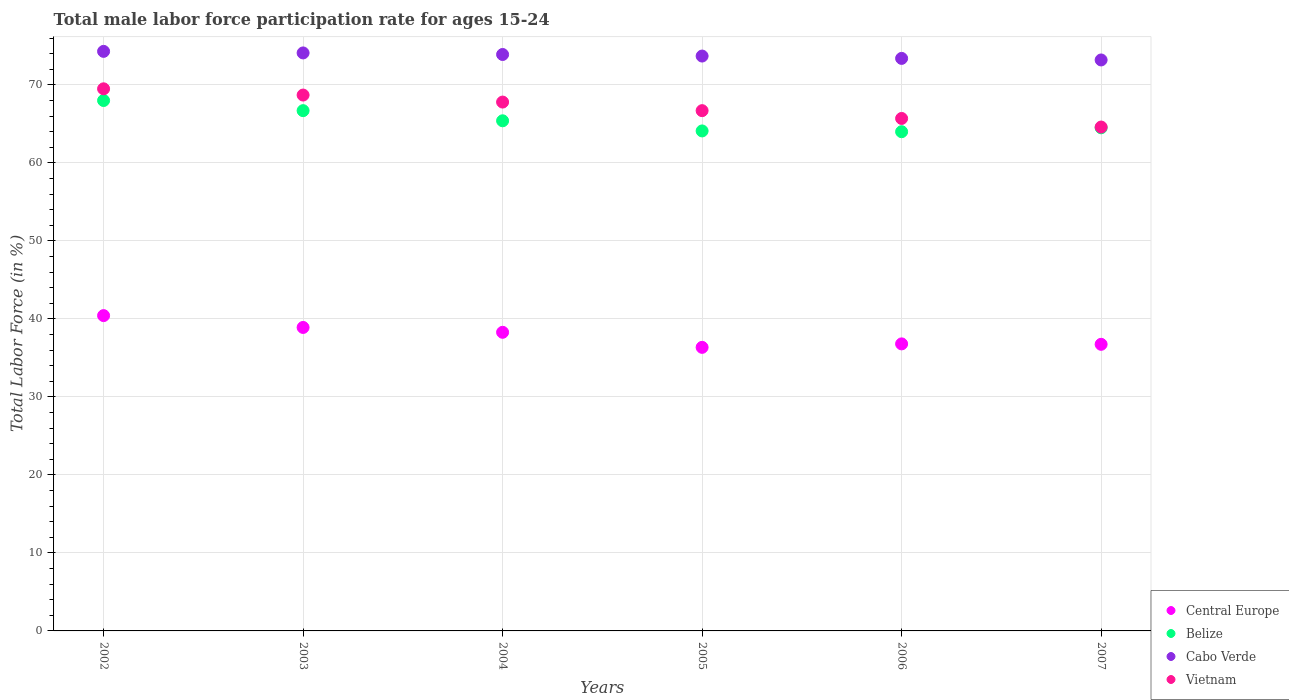How many different coloured dotlines are there?
Offer a terse response. 4. Is the number of dotlines equal to the number of legend labels?
Keep it short and to the point. Yes. What is the male labor force participation rate in Vietnam in 2005?
Provide a succinct answer. 66.7. Across all years, what is the maximum male labor force participation rate in Cabo Verde?
Your answer should be compact. 74.3. Across all years, what is the minimum male labor force participation rate in Cabo Verde?
Provide a short and direct response. 73.2. In which year was the male labor force participation rate in Central Europe minimum?
Your answer should be very brief. 2005. What is the total male labor force participation rate in Belize in the graph?
Keep it short and to the point. 392.7. What is the difference between the male labor force participation rate in Central Europe in 2002 and that in 2004?
Your response must be concise. 2.14. What is the difference between the male labor force participation rate in Belize in 2006 and the male labor force participation rate in Cabo Verde in 2003?
Your answer should be compact. -10.1. What is the average male labor force participation rate in Belize per year?
Provide a succinct answer. 65.45. In the year 2004, what is the difference between the male labor force participation rate in Vietnam and male labor force participation rate in Cabo Verde?
Keep it short and to the point. -6.1. In how many years, is the male labor force participation rate in Vietnam greater than 30 %?
Offer a terse response. 6. What is the ratio of the male labor force participation rate in Cabo Verde in 2002 to that in 2005?
Make the answer very short. 1.01. What is the difference between the highest and the second highest male labor force participation rate in Central Europe?
Your answer should be very brief. 1.52. What is the difference between the highest and the lowest male labor force participation rate in Cabo Verde?
Provide a short and direct response. 1.1. Is it the case that in every year, the sum of the male labor force participation rate in Vietnam and male labor force participation rate in Belize  is greater than the sum of male labor force participation rate in Central Europe and male labor force participation rate in Cabo Verde?
Offer a very short reply. No. Is it the case that in every year, the sum of the male labor force participation rate in Cabo Verde and male labor force participation rate in Central Europe  is greater than the male labor force participation rate in Belize?
Your answer should be compact. Yes. Does the male labor force participation rate in Belize monotonically increase over the years?
Your answer should be very brief. No. Are the values on the major ticks of Y-axis written in scientific E-notation?
Your answer should be very brief. No. Does the graph contain grids?
Your answer should be very brief. Yes. Where does the legend appear in the graph?
Ensure brevity in your answer.  Bottom right. How many legend labels are there?
Ensure brevity in your answer.  4. How are the legend labels stacked?
Your response must be concise. Vertical. What is the title of the graph?
Offer a terse response. Total male labor force participation rate for ages 15-24. Does "Bulgaria" appear as one of the legend labels in the graph?
Give a very brief answer. No. What is the label or title of the X-axis?
Make the answer very short. Years. What is the label or title of the Y-axis?
Your response must be concise. Total Labor Force (in %). What is the Total Labor Force (in %) of Central Europe in 2002?
Your answer should be compact. 40.42. What is the Total Labor Force (in %) in Belize in 2002?
Make the answer very short. 68. What is the Total Labor Force (in %) in Cabo Verde in 2002?
Provide a succinct answer. 74.3. What is the Total Labor Force (in %) in Vietnam in 2002?
Keep it short and to the point. 69.5. What is the Total Labor Force (in %) of Central Europe in 2003?
Your answer should be very brief. 38.91. What is the Total Labor Force (in %) in Belize in 2003?
Ensure brevity in your answer.  66.7. What is the Total Labor Force (in %) of Cabo Verde in 2003?
Give a very brief answer. 74.1. What is the Total Labor Force (in %) of Vietnam in 2003?
Provide a short and direct response. 68.7. What is the Total Labor Force (in %) of Central Europe in 2004?
Your answer should be compact. 38.28. What is the Total Labor Force (in %) in Belize in 2004?
Your answer should be very brief. 65.4. What is the Total Labor Force (in %) of Cabo Verde in 2004?
Your response must be concise. 73.9. What is the Total Labor Force (in %) in Vietnam in 2004?
Your answer should be very brief. 67.8. What is the Total Labor Force (in %) in Central Europe in 2005?
Offer a very short reply. 36.35. What is the Total Labor Force (in %) in Belize in 2005?
Keep it short and to the point. 64.1. What is the Total Labor Force (in %) of Cabo Verde in 2005?
Your answer should be compact. 73.7. What is the Total Labor Force (in %) in Vietnam in 2005?
Give a very brief answer. 66.7. What is the Total Labor Force (in %) in Central Europe in 2006?
Make the answer very short. 36.8. What is the Total Labor Force (in %) of Cabo Verde in 2006?
Your response must be concise. 73.4. What is the Total Labor Force (in %) of Vietnam in 2006?
Your answer should be very brief. 65.7. What is the Total Labor Force (in %) of Central Europe in 2007?
Provide a succinct answer. 36.74. What is the Total Labor Force (in %) in Belize in 2007?
Ensure brevity in your answer.  64.5. What is the Total Labor Force (in %) in Cabo Verde in 2007?
Keep it short and to the point. 73.2. What is the Total Labor Force (in %) in Vietnam in 2007?
Your answer should be very brief. 64.6. Across all years, what is the maximum Total Labor Force (in %) of Central Europe?
Your answer should be very brief. 40.42. Across all years, what is the maximum Total Labor Force (in %) of Belize?
Your answer should be very brief. 68. Across all years, what is the maximum Total Labor Force (in %) in Cabo Verde?
Provide a short and direct response. 74.3. Across all years, what is the maximum Total Labor Force (in %) of Vietnam?
Ensure brevity in your answer.  69.5. Across all years, what is the minimum Total Labor Force (in %) in Central Europe?
Give a very brief answer. 36.35. Across all years, what is the minimum Total Labor Force (in %) in Belize?
Offer a terse response. 64. Across all years, what is the minimum Total Labor Force (in %) in Cabo Verde?
Your answer should be compact. 73.2. Across all years, what is the minimum Total Labor Force (in %) in Vietnam?
Make the answer very short. 64.6. What is the total Total Labor Force (in %) of Central Europe in the graph?
Your answer should be very brief. 227.51. What is the total Total Labor Force (in %) of Belize in the graph?
Keep it short and to the point. 392.7. What is the total Total Labor Force (in %) of Cabo Verde in the graph?
Give a very brief answer. 442.6. What is the total Total Labor Force (in %) of Vietnam in the graph?
Keep it short and to the point. 403. What is the difference between the Total Labor Force (in %) in Central Europe in 2002 and that in 2003?
Give a very brief answer. 1.52. What is the difference between the Total Labor Force (in %) of Belize in 2002 and that in 2003?
Provide a succinct answer. 1.3. What is the difference between the Total Labor Force (in %) of Cabo Verde in 2002 and that in 2003?
Offer a very short reply. 0.2. What is the difference between the Total Labor Force (in %) of Vietnam in 2002 and that in 2003?
Make the answer very short. 0.8. What is the difference between the Total Labor Force (in %) in Central Europe in 2002 and that in 2004?
Your response must be concise. 2.14. What is the difference between the Total Labor Force (in %) in Cabo Verde in 2002 and that in 2004?
Your answer should be very brief. 0.4. What is the difference between the Total Labor Force (in %) in Central Europe in 2002 and that in 2005?
Provide a short and direct response. 4.07. What is the difference between the Total Labor Force (in %) of Belize in 2002 and that in 2005?
Your response must be concise. 3.9. What is the difference between the Total Labor Force (in %) in Cabo Verde in 2002 and that in 2005?
Provide a succinct answer. 0.6. What is the difference between the Total Labor Force (in %) of Vietnam in 2002 and that in 2005?
Your answer should be very brief. 2.8. What is the difference between the Total Labor Force (in %) of Central Europe in 2002 and that in 2006?
Your response must be concise. 3.62. What is the difference between the Total Labor Force (in %) in Belize in 2002 and that in 2006?
Make the answer very short. 4. What is the difference between the Total Labor Force (in %) in Central Europe in 2002 and that in 2007?
Your response must be concise. 3.68. What is the difference between the Total Labor Force (in %) in Central Europe in 2003 and that in 2004?
Provide a short and direct response. 0.62. What is the difference between the Total Labor Force (in %) in Belize in 2003 and that in 2004?
Your response must be concise. 1.3. What is the difference between the Total Labor Force (in %) of Cabo Verde in 2003 and that in 2004?
Provide a succinct answer. 0.2. What is the difference between the Total Labor Force (in %) in Central Europe in 2003 and that in 2005?
Offer a very short reply. 2.55. What is the difference between the Total Labor Force (in %) of Central Europe in 2003 and that in 2006?
Your answer should be very brief. 2.11. What is the difference between the Total Labor Force (in %) of Belize in 2003 and that in 2006?
Provide a succinct answer. 2.7. What is the difference between the Total Labor Force (in %) of Central Europe in 2003 and that in 2007?
Offer a terse response. 2.16. What is the difference between the Total Labor Force (in %) in Belize in 2003 and that in 2007?
Offer a terse response. 2.2. What is the difference between the Total Labor Force (in %) of Central Europe in 2004 and that in 2005?
Make the answer very short. 1.93. What is the difference between the Total Labor Force (in %) in Belize in 2004 and that in 2005?
Offer a very short reply. 1.3. What is the difference between the Total Labor Force (in %) of Vietnam in 2004 and that in 2005?
Give a very brief answer. 1.1. What is the difference between the Total Labor Force (in %) in Central Europe in 2004 and that in 2006?
Offer a very short reply. 1.49. What is the difference between the Total Labor Force (in %) in Central Europe in 2004 and that in 2007?
Your answer should be very brief. 1.54. What is the difference between the Total Labor Force (in %) of Belize in 2004 and that in 2007?
Offer a terse response. 0.9. What is the difference between the Total Labor Force (in %) in Central Europe in 2005 and that in 2006?
Your answer should be very brief. -0.44. What is the difference between the Total Labor Force (in %) of Cabo Verde in 2005 and that in 2006?
Keep it short and to the point. 0.3. What is the difference between the Total Labor Force (in %) of Vietnam in 2005 and that in 2006?
Your answer should be compact. 1. What is the difference between the Total Labor Force (in %) in Central Europe in 2005 and that in 2007?
Offer a very short reply. -0.39. What is the difference between the Total Labor Force (in %) of Belize in 2005 and that in 2007?
Provide a short and direct response. -0.4. What is the difference between the Total Labor Force (in %) in Cabo Verde in 2005 and that in 2007?
Provide a short and direct response. 0.5. What is the difference between the Total Labor Force (in %) in Central Europe in 2006 and that in 2007?
Give a very brief answer. 0.06. What is the difference between the Total Labor Force (in %) in Central Europe in 2002 and the Total Labor Force (in %) in Belize in 2003?
Provide a short and direct response. -26.28. What is the difference between the Total Labor Force (in %) of Central Europe in 2002 and the Total Labor Force (in %) of Cabo Verde in 2003?
Make the answer very short. -33.68. What is the difference between the Total Labor Force (in %) in Central Europe in 2002 and the Total Labor Force (in %) in Vietnam in 2003?
Your response must be concise. -28.28. What is the difference between the Total Labor Force (in %) of Belize in 2002 and the Total Labor Force (in %) of Cabo Verde in 2003?
Give a very brief answer. -6.1. What is the difference between the Total Labor Force (in %) in Cabo Verde in 2002 and the Total Labor Force (in %) in Vietnam in 2003?
Offer a terse response. 5.6. What is the difference between the Total Labor Force (in %) in Central Europe in 2002 and the Total Labor Force (in %) in Belize in 2004?
Make the answer very short. -24.98. What is the difference between the Total Labor Force (in %) in Central Europe in 2002 and the Total Labor Force (in %) in Cabo Verde in 2004?
Your answer should be compact. -33.48. What is the difference between the Total Labor Force (in %) of Central Europe in 2002 and the Total Labor Force (in %) of Vietnam in 2004?
Keep it short and to the point. -27.38. What is the difference between the Total Labor Force (in %) in Belize in 2002 and the Total Labor Force (in %) in Vietnam in 2004?
Keep it short and to the point. 0.2. What is the difference between the Total Labor Force (in %) in Central Europe in 2002 and the Total Labor Force (in %) in Belize in 2005?
Keep it short and to the point. -23.68. What is the difference between the Total Labor Force (in %) of Central Europe in 2002 and the Total Labor Force (in %) of Cabo Verde in 2005?
Offer a very short reply. -33.28. What is the difference between the Total Labor Force (in %) of Central Europe in 2002 and the Total Labor Force (in %) of Vietnam in 2005?
Offer a very short reply. -26.28. What is the difference between the Total Labor Force (in %) of Cabo Verde in 2002 and the Total Labor Force (in %) of Vietnam in 2005?
Offer a terse response. 7.6. What is the difference between the Total Labor Force (in %) in Central Europe in 2002 and the Total Labor Force (in %) in Belize in 2006?
Make the answer very short. -23.58. What is the difference between the Total Labor Force (in %) in Central Europe in 2002 and the Total Labor Force (in %) in Cabo Verde in 2006?
Ensure brevity in your answer.  -32.98. What is the difference between the Total Labor Force (in %) of Central Europe in 2002 and the Total Labor Force (in %) of Vietnam in 2006?
Ensure brevity in your answer.  -25.28. What is the difference between the Total Labor Force (in %) of Cabo Verde in 2002 and the Total Labor Force (in %) of Vietnam in 2006?
Provide a short and direct response. 8.6. What is the difference between the Total Labor Force (in %) of Central Europe in 2002 and the Total Labor Force (in %) of Belize in 2007?
Provide a short and direct response. -24.08. What is the difference between the Total Labor Force (in %) of Central Europe in 2002 and the Total Labor Force (in %) of Cabo Verde in 2007?
Give a very brief answer. -32.78. What is the difference between the Total Labor Force (in %) of Central Europe in 2002 and the Total Labor Force (in %) of Vietnam in 2007?
Offer a very short reply. -24.18. What is the difference between the Total Labor Force (in %) of Cabo Verde in 2002 and the Total Labor Force (in %) of Vietnam in 2007?
Keep it short and to the point. 9.7. What is the difference between the Total Labor Force (in %) of Central Europe in 2003 and the Total Labor Force (in %) of Belize in 2004?
Offer a terse response. -26.49. What is the difference between the Total Labor Force (in %) in Central Europe in 2003 and the Total Labor Force (in %) in Cabo Verde in 2004?
Your answer should be very brief. -34.99. What is the difference between the Total Labor Force (in %) of Central Europe in 2003 and the Total Labor Force (in %) of Vietnam in 2004?
Offer a terse response. -28.89. What is the difference between the Total Labor Force (in %) in Belize in 2003 and the Total Labor Force (in %) in Vietnam in 2004?
Your answer should be very brief. -1.1. What is the difference between the Total Labor Force (in %) in Central Europe in 2003 and the Total Labor Force (in %) in Belize in 2005?
Offer a very short reply. -25.19. What is the difference between the Total Labor Force (in %) in Central Europe in 2003 and the Total Labor Force (in %) in Cabo Verde in 2005?
Give a very brief answer. -34.79. What is the difference between the Total Labor Force (in %) in Central Europe in 2003 and the Total Labor Force (in %) in Vietnam in 2005?
Provide a succinct answer. -27.79. What is the difference between the Total Labor Force (in %) of Central Europe in 2003 and the Total Labor Force (in %) of Belize in 2006?
Provide a succinct answer. -25.09. What is the difference between the Total Labor Force (in %) in Central Europe in 2003 and the Total Labor Force (in %) in Cabo Verde in 2006?
Ensure brevity in your answer.  -34.49. What is the difference between the Total Labor Force (in %) in Central Europe in 2003 and the Total Labor Force (in %) in Vietnam in 2006?
Keep it short and to the point. -26.79. What is the difference between the Total Labor Force (in %) in Belize in 2003 and the Total Labor Force (in %) in Cabo Verde in 2006?
Your answer should be compact. -6.7. What is the difference between the Total Labor Force (in %) of Belize in 2003 and the Total Labor Force (in %) of Vietnam in 2006?
Offer a very short reply. 1. What is the difference between the Total Labor Force (in %) of Cabo Verde in 2003 and the Total Labor Force (in %) of Vietnam in 2006?
Your answer should be compact. 8.4. What is the difference between the Total Labor Force (in %) of Central Europe in 2003 and the Total Labor Force (in %) of Belize in 2007?
Offer a very short reply. -25.59. What is the difference between the Total Labor Force (in %) in Central Europe in 2003 and the Total Labor Force (in %) in Cabo Verde in 2007?
Make the answer very short. -34.29. What is the difference between the Total Labor Force (in %) in Central Europe in 2003 and the Total Labor Force (in %) in Vietnam in 2007?
Your answer should be compact. -25.69. What is the difference between the Total Labor Force (in %) in Belize in 2003 and the Total Labor Force (in %) in Vietnam in 2007?
Give a very brief answer. 2.1. What is the difference between the Total Labor Force (in %) in Central Europe in 2004 and the Total Labor Force (in %) in Belize in 2005?
Make the answer very short. -25.82. What is the difference between the Total Labor Force (in %) in Central Europe in 2004 and the Total Labor Force (in %) in Cabo Verde in 2005?
Provide a succinct answer. -35.42. What is the difference between the Total Labor Force (in %) of Central Europe in 2004 and the Total Labor Force (in %) of Vietnam in 2005?
Keep it short and to the point. -28.42. What is the difference between the Total Labor Force (in %) in Cabo Verde in 2004 and the Total Labor Force (in %) in Vietnam in 2005?
Give a very brief answer. 7.2. What is the difference between the Total Labor Force (in %) in Central Europe in 2004 and the Total Labor Force (in %) in Belize in 2006?
Offer a very short reply. -25.72. What is the difference between the Total Labor Force (in %) in Central Europe in 2004 and the Total Labor Force (in %) in Cabo Verde in 2006?
Give a very brief answer. -35.12. What is the difference between the Total Labor Force (in %) in Central Europe in 2004 and the Total Labor Force (in %) in Vietnam in 2006?
Give a very brief answer. -27.42. What is the difference between the Total Labor Force (in %) of Cabo Verde in 2004 and the Total Labor Force (in %) of Vietnam in 2006?
Make the answer very short. 8.2. What is the difference between the Total Labor Force (in %) in Central Europe in 2004 and the Total Labor Force (in %) in Belize in 2007?
Offer a very short reply. -26.22. What is the difference between the Total Labor Force (in %) in Central Europe in 2004 and the Total Labor Force (in %) in Cabo Verde in 2007?
Your answer should be compact. -34.92. What is the difference between the Total Labor Force (in %) of Central Europe in 2004 and the Total Labor Force (in %) of Vietnam in 2007?
Give a very brief answer. -26.32. What is the difference between the Total Labor Force (in %) of Belize in 2004 and the Total Labor Force (in %) of Cabo Verde in 2007?
Give a very brief answer. -7.8. What is the difference between the Total Labor Force (in %) in Belize in 2004 and the Total Labor Force (in %) in Vietnam in 2007?
Your response must be concise. 0.8. What is the difference between the Total Labor Force (in %) of Central Europe in 2005 and the Total Labor Force (in %) of Belize in 2006?
Keep it short and to the point. -27.65. What is the difference between the Total Labor Force (in %) of Central Europe in 2005 and the Total Labor Force (in %) of Cabo Verde in 2006?
Give a very brief answer. -37.05. What is the difference between the Total Labor Force (in %) of Central Europe in 2005 and the Total Labor Force (in %) of Vietnam in 2006?
Offer a terse response. -29.35. What is the difference between the Total Labor Force (in %) in Belize in 2005 and the Total Labor Force (in %) in Cabo Verde in 2006?
Give a very brief answer. -9.3. What is the difference between the Total Labor Force (in %) of Cabo Verde in 2005 and the Total Labor Force (in %) of Vietnam in 2006?
Offer a terse response. 8. What is the difference between the Total Labor Force (in %) of Central Europe in 2005 and the Total Labor Force (in %) of Belize in 2007?
Your answer should be compact. -28.15. What is the difference between the Total Labor Force (in %) in Central Europe in 2005 and the Total Labor Force (in %) in Cabo Verde in 2007?
Your answer should be compact. -36.85. What is the difference between the Total Labor Force (in %) in Central Europe in 2005 and the Total Labor Force (in %) in Vietnam in 2007?
Keep it short and to the point. -28.25. What is the difference between the Total Labor Force (in %) in Belize in 2005 and the Total Labor Force (in %) in Cabo Verde in 2007?
Your answer should be very brief. -9.1. What is the difference between the Total Labor Force (in %) in Cabo Verde in 2005 and the Total Labor Force (in %) in Vietnam in 2007?
Ensure brevity in your answer.  9.1. What is the difference between the Total Labor Force (in %) in Central Europe in 2006 and the Total Labor Force (in %) in Belize in 2007?
Ensure brevity in your answer.  -27.7. What is the difference between the Total Labor Force (in %) in Central Europe in 2006 and the Total Labor Force (in %) in Cabo Verde in 2007?
Your answer should be compact. -36.4. What is the difference between the Total Labor Force (in %) of Central Europe in 2006 and the Total Labor Force (in %) of Vietnam in 2007?
Make the answer very short. -27.8. What is the difference between the Total Labor Force (in %) in Belize in 2006 and the Total Labor Force (in %) in Cabo Verde in 2007?
Give a very brief answer. -9.2. What is the average Total Labor Force (in %) in Central Europe per year?
Your answer should be compact. 37.92. What is the average Total Labor Force (in %) of Belize per year?
Make the answer very short. 65.45. What is the average Total Labor Force (in %) of Cabo Verde per year?
Your answer should be very brief. 73.77. What is the average Total Labor Force (in %) in Vietnam per year?
Keep it short and to the point. 67.17. In the year 2002, what is the difference between the Total Labor Force (in %) of Central Europe and Total Labor Force (in %) of Belize?
Provide a short and direct response. -27.58. In the year 2002, what is the difference between the Total Labor Force (in %) of Central Europe and Total Labor Force (in %) of Cabo Verde?
Give a very brief answer. -33.88. In the year 2002, what is the difference between the Total Labor Force (in %) in Central Europe and Total Labor Force (in %) in Vietnam?
Offer a terse response. -29.08. In the year 2002, what is the difference between the Total Labor Force (in %) of Belize and Total Labor Force (in %) of Cabo Verde?
Your answer should be compact. -6.3. In the year 2003, what is the difference between the Total Labor Force (in %) in Central Europe and Total Labor Force (in %) in Belize?
Provide a succinct answer. -27.79. In the year 2003, what is the difference between the Total Labor Force (in %) of Central Europe and Total Labor Force (in %) of Cabo Verde?
Provide a short and direct response. -35.19. In the year 2003, what is the difference between the Total Labor Force (in %) of Central Europe and Total Labor Force (in %) of Vietnam?
Make the answer very short. -29.79. In the year 2003, what is the difference between the Total Labor Force (in %) in Belize and Total Labor Force (in %) in Cabo Verde?
Provide a short and direct response. -7.4. In the year 2003, what is the difference between the Total Labor Force (in %) of Belize and Total Labor Force (in %) of Vietnam?
Provide a succinct answer. -2. In the year 2004, what is the difference between the Total Labor Force (in %) in Central Europe and Total Labor Force (in %) in Belize?
Ensure brevity in your answer.  -27.12. In the year 2004, what is the difference between the Total Labor Force (in %) of Central Europe and Total Labor Force (in %) of Cabo Verde?
Ensure brevity in your answer.  -35.62. In the year 2004, what is the difference between the Total Labor Force (in %) of Central Europe and Total Labor Force (in %) of Vietnam?
Your response must be concise. -29.52. In the year 2004, what is the difference between the Total Labor Force (in %) of Belize and Total Labor Force (in %) of Cabo Verde?
Offer a very short reply. -8.5. In the year 2004, what is the difference between the Total Labor Force (in %) in Cabo Verde and Total Labor Force (in %) in Vietnam?
Make the answer very short. 6.1. In the year 2005, what is the difference between the Total Labor Force (in %) of Central Europe and Total Labor Force (in %) of Belize?
Ensure brevity in your answer.  -27.75. In the year 2005, what is the difference between the Total Labor Force (in %) of Central Europe and Total Labor Force (in %) of Cabo Verde?
Keep it short and to the point. -37.35. In the year 2005, what is the difference between the Total Labor Force (in %) in Central Europe and Total Labor Force (in %) in Vietnam?
Ensure brevity in your answer.  -30.35. In the year 2005, what is the difference between the Total Labor Force (in %) of Belize and Total Labor Force (in %) of Vietnam?
Your answer should be compact. -2.6. In the year 2006, what is the difference between the Total Labor Force (in %) of Central Europe and Total Labor Force (in %) of Belize?
Offer a terse response. -27.2. In the year 2006, what is the difference between the Total Labor Force (in %) in Central Europe and Total Labor Force (in %) in Cabo Verde?
Provide a short and direct response. -36.6. In the year 2006, what is the difference between the Total Labor Force (in %) of Central Europe and Total Labor Force (in %) of Vietnam?
Your answer should be compact. -28.9. In the year 2006, what is the difference between the Total Labor Force (in %) in Belize and Total Labor Force (in %) in Vietnam?
Your answer should be very brief. -1.7. In the year 2006, what is the difference between the Total Labor Force (in %) of Cabo Verde and Total Labor Force (in %) of Vietnam?
Keep it short and to the point. 7.7. In the year 2007, what is the difference between the Total Labor Force (in %) in Central Europe and Total Labor Force (in %) in Belize?
Provide a succinct answer. -27.76. In the year 2007, what is the difference between the Total Labor Force (in %) in Central Europe and Total Labor Force (in %) in Cabo Verde?
Give a very brief answer. -36.46. In the year 2007, what is the difference between the Total Labor Force (in %) in Central Europe and Total Labor Force (in %) in Vietnam?
Make the answer very short. -27.86. In the year 2007, what is the difference between the Total Labor Force (in %) in Belize and Total Labor Force (in %) in Vietnam?
Ensure brevity in your answer.  -0.1. What is the ratio of the Total Labor Force (in %) of Central Europe in 2002 to that in 2003?
Offer a terse response. 1.04. What is the ratio of the Total Labor Force (in %) in Belize in 2002 to that in 2003?
Provide a short and direct response. 1.02. What is the ratio of the Total Labor Force (in %) of Cabo Verde in 2002 to that in 2003?
Offer a terse response. 1. What is the ratio of the Total Labor Force (in %) of Vietnam in 2002 to that in 2003?
Make the answer very short. 1.01. What is the ratio of the Total Labor Force (in %) of Central Europe in 2002 to that in 2004?
Make the answer very short. 1.06. What is the ratio of the Total Labor Force (in %) of Belize in 2002 to that in 2004?
Your response must be concise. 1.04. What is the ratio of the Total Labor Force (in %) of Cabo Verde in 2002 to that in 2004?
Your answer should be compact. 1.01. What is the ratio of the Total Labor Force (in %) of Vietnam in 2002 to that in 2004?
Your answer should be compact. 1.03. What is the ratio of the Total Labor Force (in %) in Central Europe in 2002 to that in 2005?
Give a very brief answer. 1.11. What is the ratio of the Total Labor Force (in %) of Belize in 2002 to that in 2005?
Your response must be concise. 1.06. What is the ratio of the Total Labor Force (in %) in Cabo Verde in 2002 to that in 2005?
Your answer should be compact. 1.01. What is the ratio of the Total Labor Force (in %) in Vietnam in 2002 to that in 2005?
Your answer should be compact. 1.04. What is the ratio of the Total Labor Force (in %) of Central Europe in 2002 to that in 2006?
Provide a succinct answer. 1.1. What is the ratio of the Total Labor Force (in %) of Belize in 2002 to that in 2006?
Offer a very short reply. 1.06. What is the ratio of the Total Labor Force (in %) in Cabo Verde in 2002 to that in 2006?
Provide a succinct answer. 1.01. What is the ratio of the Total Labor Force (in %) in Vietnam in 2002 to that in 2006?
Ensure brevity in your answer.  1.06. What is the ratio of the Total Labor Force (in %) of Central Europe in 2002 to that in 2007?
Keep it short and to the point. 1.1. What is the ratio of the Total Labor Force (in %) of Belize in 2002 to that in 2007?
Provide a short and direct response. 1.05. What is the ratio of the Total Labor Force (in %) in Cabo Verde in 2002 to that in 2007?
Offer a terse response. 1.01. What is the ratio of the Total Labor Force (in %) in Vietnam in 2002 to that in 2007?
Make the answer very short. 1.08. What is the ratio of the Total Labor Force (in %) in Central Europe in 2003 to that in 2004?
Your response must be concise. 1.02. What is the ratio of the Total Labor Force (in %) of Belize in 2003 to that in 2004?
Your response must be concise. 1.02. What is the ratio of the Total Labor Force (in %) of Cabo Verde in 2003 to that in 2004?
Provide a succinct answer. 1. What is the ratio of the Total Labor Force (in %) of Vietnam in 2003 to that in 2004?
Provide a succinct answer. 1.01. What is the ratio of the Total Labor Force (in %) in Central Europe in 2003 to that in 2005?
Your answer should be compact. 1.07. What is the ratio of the Total Labor Force (in %) of Belize in 2003 to that in 2005?
Your response must be concise. 1.04. What is the ratio of the Total Labor Force (in %) of Cabo Verde in 2003 to that in 2005?
Give a very brief answer. 1.01. What is the ratio of the Total Labor Force (in %) of Central Europe in 2003 to that in 2006?
Provide a succinct answer. 1.06. What is the ratio of the Total Labor Force (in %) in Belize in 2003 to that in 2006?
Your response must be concise. 1.04. What is the ratio of the Total Labor Force (in %) in Cabo Verde in 2003 to that in 2006?
Give a very brief answer. 1.01. What is the ratio of the Total Labor Force (in %) of Vietnam in 2003 to that in 2006?
Your answer should be compact. 1.05. What is the ratio of the Total Labor Force (in %) of Central Europe in 2003 to that in 2007?
Your response must be concise. 1.06. What is the ratio of the Total Labor Force (in %) of Belize in 2003 to that in 2007?
Keep it short and to the point. 1.03. What is the ratio of the Total Labor Force (in %) in Cabo Verde in 2003 to that in 2007?
Give a very brief answer. 1.01. What is the ratio of the Total Labor Force (in %) in Vietnam in 2003 to that in 2007?
Give a very brief answer. 1.06. What is the ratio of the Total Labor Force (in %) of Central Europe in 2004 to that in 2005?
Offer a very short reply. 1.05. What is the ratio of the Total Labor Force (in %) in Belize in 2004 to that in 2005?
Your answer should be very brief. 1.02. What is the ratio of the Total Labor Force (in %) in Cabo Verde in 2004 to that in 2005?
Offer a terse response. 1. What is the ratio of the Total Labor Force (in %) of Vietnam in 2004 to that in 2005?
Make the answer very short. 1.02. What is the ratio of the Total Labor Force (in %) in Central Europe in 2004 to that in 2006?
Your response must be concise. 1.04. What is the ratio of the Total Labor Force (in %) of Belize in 2004 to that in 2006?
Your answer should be very brief. 1.02. What is the ratio of the Total Labor Force (in %) of Cabo Verde in 2004 to that in 2006?
Offer a very short reply. 1.01. What is the ratio of the Total Labor Force (in %) in Vietnam in 2004 to that in 2006?
Your answer should be compact. 1.03. What is the ratio of the Total Labor Force (in %) of Central Europe in 2004 to that in 2007?
Offer a very short reply. 1.04. What is the ratio of the Total Labor Force (in %) in Cabo Verde in 2004 to that in 2007?
Your response must be concise. 1.01. What is the ratio of the Total Labor Force (in %) of Vietnam in 2004 to that in 2007?
Offer a terse response. 1.05. What is the ratio of the Total Labor Force (in %) in Central Europe in 2005 to that in 2006?
Your response must be concise. 0.99. What is the ratio of the Total Labor Force (in %) in Belize in 2005 to that in 2006?
Keep it short and to the point. 1. What is the ratio of the Total Labor Force (in %) in Vietnam in 2005 to that in 2006?
Your answer should be compact. 1.02. What is the ratio of the Total Labor Force (in %) in Central Europe in 2005 to that in 2007?
Your answer should be compact. 0.99. What is the ratio of the Total Labor Force (in %) of Cabo Verde in 2005 to that in 2007?
Your response must be concise. 1.01. What is the ratio of the Total Labor Force (in %) of Vietnam in 2005 to that in 2007?
Make the answer very short. 1.03. What is the ratio of the Total Labor Force (in %) of Central Europe in 2006 to that in 2007?
Provide a succinct answer. 1. What is the ratio of the Total Labor Force (in %) of Vietnam in 2006 to that in 2007?
Keep it short and to the point. 1.02. What is the difference between the highest and the second highest Total Labor Force (in %) in Central Europe?
Give a very brief answer. 1.52. What is the difference between the highest and the second highest Total Labor Force (in %) of Belize?
Keep it short and to the point. 1.3. What is the difference between the highest and the second highest Total Labor Force (in %) of Vietnam?
Offer a very short reply. 0.8. What is the difference between the highest and the lowest Total Labor Force (in %) in Central Europe?
Offer a terse response. 4.07. What is the difference between the highest and the lowest Total Labor Force (in %) in Belize?
Your answer should be compact. 4. What is the difference between the highest and the lowest Total Labor Force (in %) of Cabo Verde?
Keep it short and to the point. 1.1. 